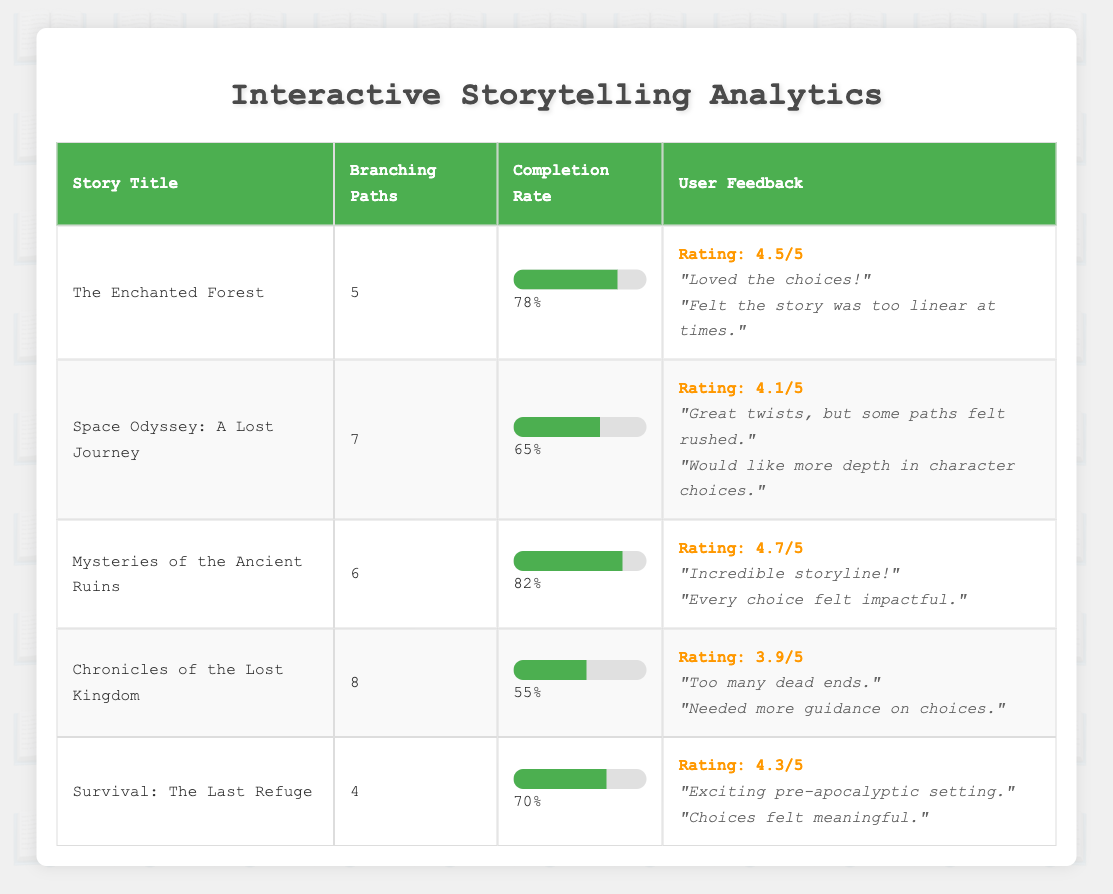What is the highest completion rate among the stories? By examining the completion rates listed in the table, the highest value is found for "Mysteries of the Ancient Ruins" at 82%.
Answer: 82% Which story has the lowest average rating? Comparing the average ratings in the table, "Chronicles of the Lost Kingdom" has the lowest average rating at 3.9.
Answer: 3.9 How many branching paths does "Space Odyssey: A Lost Journey" have? The table shows that "Space Odyssey: A Lost Journey" includes 7 branching paths as indicated in the relevant column.
Answer: 7 Is the completion rate of "The Enchanted Forest" greater than that of "Survival: The Last Refuge"? The completion rate for "The Enchanted Forest" is 78%, which is indeed greater than "Survival: The Last Refuge" at 70%. Thus, the answer is yes.
Answer: Yes What is the average completion rate of all listed stories? To find the average, sum the completion rates (78 + 65 + 82 + 55 + 70 = 350) and divide by the number of stories (5). Thus, 350 / 5 = 70.
Answer: 70 Which story had comments indicating a need for more depth in character choices? The user feedback for "Space Odyssey: A Lost Journey" includes the comment, "Would like more depth in character choices."
Answer: Space Odyssey: A Lost Journey How many stories have a completion rate above 75%? The stories with completion rates above 75% are "The Enchanted Forest" (78%), "Mysteries of the Ancient Ruins" (82%), and "Survival: The Last Refuge" (70%). Thus, 2 stories meet this criterion.
Answer: 2 Can we say that users rated "Chronicles of the Lost Kingdom" positively? Since "Chronicles of the Lost Kingdom" has an average rating of 3.9, which is below 4.0, it does not indicate a particularly positive reception by users. So, the answer is no.
Answer: No What is the difference in completion rates between "The Enchanted Forest" and "Chronicles of the Lost Kingdom"? The completion rate for "The Enchanted Forest" is 78%, and for "Chronicles of the Lost Kingdom" it is 55%. The difference is 78 - 55 = 23%.
Answer: 23% 